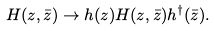<formula> <loc_0><loc_0><loc_500><loc_500>H ( z , \bar { z } ) \to h ( z ) H ( z , \bar { z } ) h ^ { \dagger } ( \bar { z } ) .</formula> 